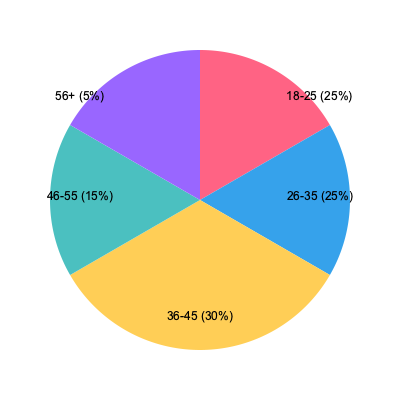Based on the pie chart showing customer age demographics, which two age groups combined make up 50% of your shop's customer base, and how might this information influence your product selection and marketing strategies? To answer this question, we need to analyze the pie chart and follow these steps:

1. Identify the age groups and their percentages:
   - 18-25: 25%
   - 26-35: 25%
   - 36-45: 30%
   - 46-55: 15%
   - 56+: 5%

2. Find the two age groups that combined make up 50% of the customer base:
   The 18-25 and 26-35 age groups each represent 25%, and together they make up 50% of the customer base.

3. Consider how this information might influence product selection and marketing strategies:
   a) Product selection:
      - Focus on products that appeal to young adults and millennials (18-35 age range)
      - Consider trendy, unique, and innovative products that resonate with these age groups
      - Stock items related to career development, home decor, and lifestyle products popular among young professionals

   b) Marketing strategies:
      - Utilize social media platforms popular among younger demographics (e.g., Instagram, TikTok)
      - Create content that speaks to the interests and values of the 18-35 age group
      - Implement loyalty programs or referral incentives that appeal to younger customers
      - Host events or workshops tailored to young adults' interests
      - Collaborate with local influencers or brands that resonate with this demographic

4. Cross-promotion and community-building:
   - Partner with local businesses that cater to the 18-35 age group (e.g., fitness studios, coffee shops, co-working spaces)
   - Create a community space within the shop for young professionals to network or attend workshops
   - Offer complementary products that enhance the lifestyle of young adults (e.g., eco-friendly items, productivity tools)

By focusing on the preferences and needs of the 18-35 age group while still maintaining a diverse product range, the shop can capitalize on its largest customer segment while fostering a sense of community and encouraging cross-promotion.
Answer: 18-25 and 26-35; focus on young adult preferences, use social media marketing, and create community-oriented events and partnerships. 